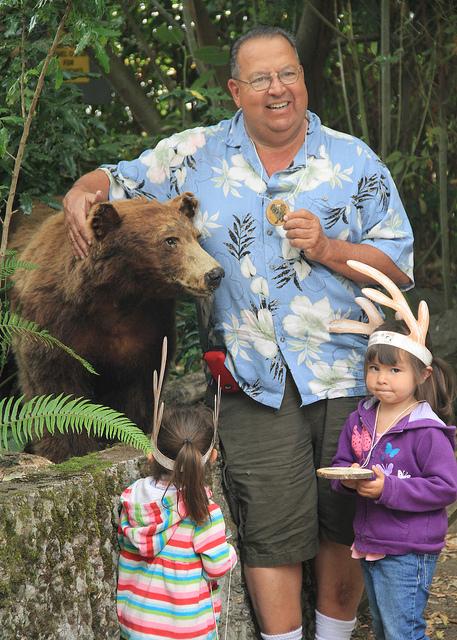Is the girl wearing a scarf?
Keep it brief. No. Is this animal real?
Keep it brief. No. What animal is behind the person?
Keep it brief. Bear. Are the things on the childrens' heads formal hats, like the kind you would wear to a wedding?
Concise answer only. No. What type of jackets are the children wearing?
Answer briefly. Hoodies. 